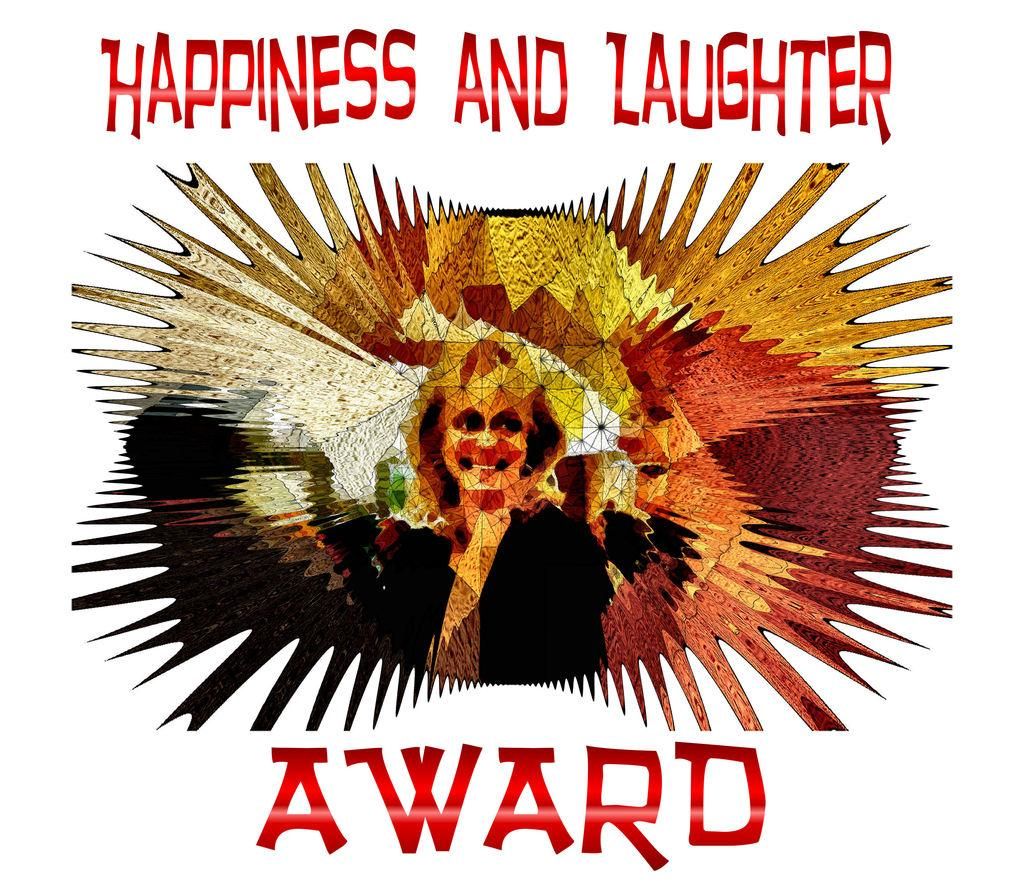What type of image is being described? The image is a graphic. What is depicted in the graphic? There is a picture of a person in the image. Are there any words or letters in the image? Yes, there is text in the image. What is the health status of the person depicted in the image? The provided facts do not mention any information about the health status of the person in the image. 